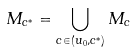<formula> <loc_0><loc_0><loc_500><loc_500>M _ { c ^ { * } } = \bigcup _ { c \in ( u _ { 0 } , c ^ { * } ) } M _ { c }</formula> 